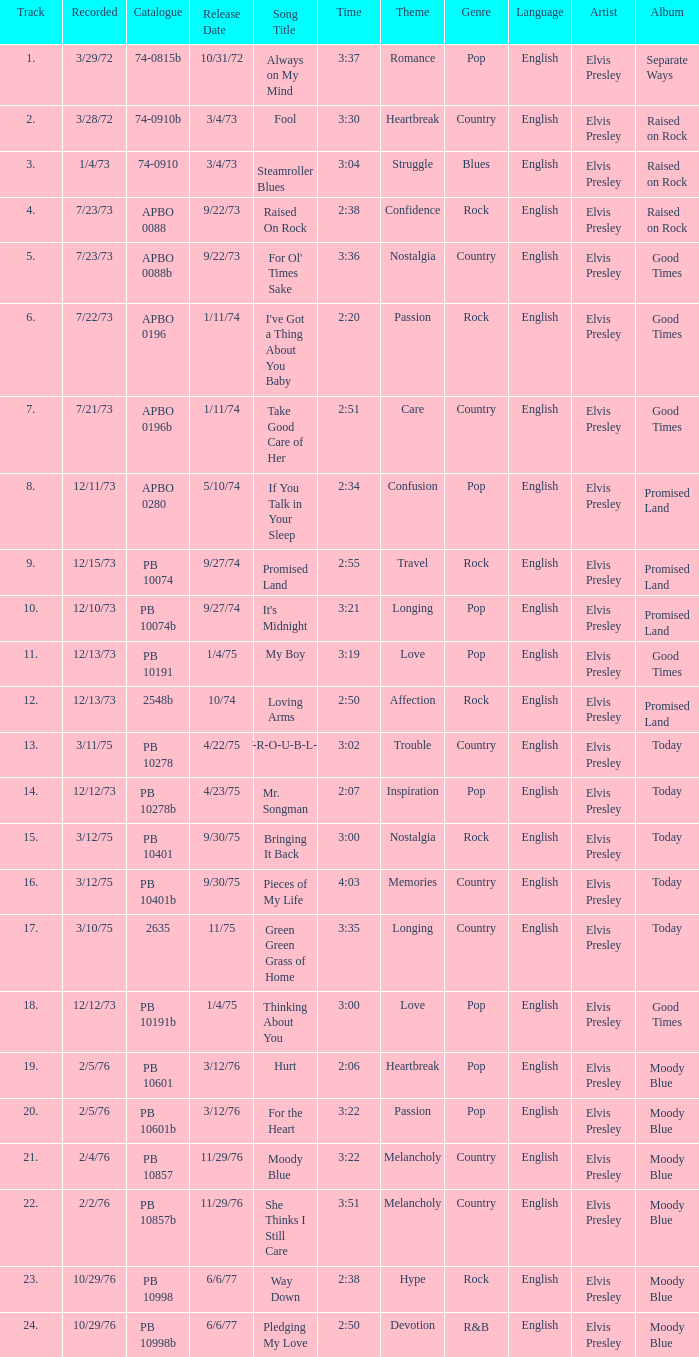I want the sum of tracks for raised on rock 4.0. 